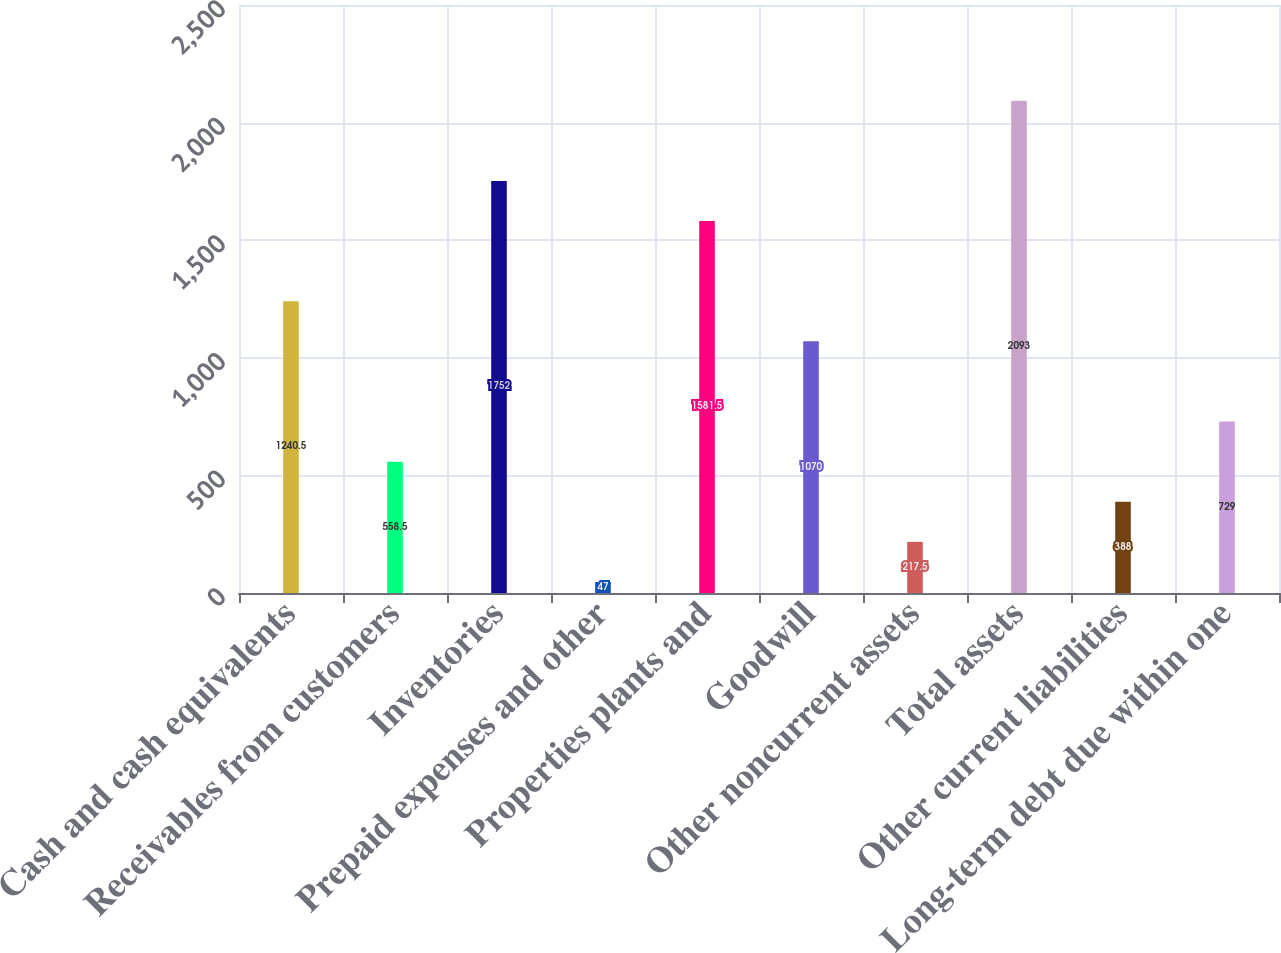<chart> <loc_0><loc_0><loc_500><loc_500><bar_chart><fcel>Cash and cash equivalents<fcel>Receivables from customers<fcel>Inventories<fcel>Prepaid expenses and other<fcel>Properties plants and<fcel>Goodwill<fcel>Other noncurrent assets<fcel>Total assets<fcel>Other current liabilities<fcel>Long-term debt due within one<nl><fcel>1240.5<fcel>558.5<fcel>1752<fcel>47<fcel>1581.5<fcel>1070<fcel>217.5<fcel>2093<fcel>388<fcel>729<nl></chart> 